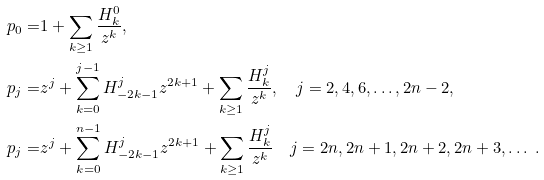<formula> <loc_0><loc_0><loc_500><loc_500>p _ { 0 } = & 1 + \sum _ { k \geq 1 } \frac { H ^ { 0 } _ { k } } { z ^ { k } } , \\ p _ { j } = & z ^ { j } + \sum _ { k = 0 } ^ { j - 1 } H ^ { j } _ { - 2 k - 1 } z ^ { 2 k + 1 } + \sum _ { k \geq 1 } \frac { H ^ { j } _ { k } } { z ^ { k } } , \quad j = 2 , 4 , 6 , \dots , 2 n - 2 , \\ p _ { j } = & z ^ { j } + \sum _ { k = 0 } ^ { n - 1 } H ^ { j } _ { - 2 k - 1 } z ^ { 2 k + 1 } + \sum _ { k \geq 1 } \frac { H ^ { j } _ { k } } { z ^ { k } } \quad j = 2 n , 2 n + 1 , 2 n + 2 , 2 n + 3 , \dots \ .</formula> 